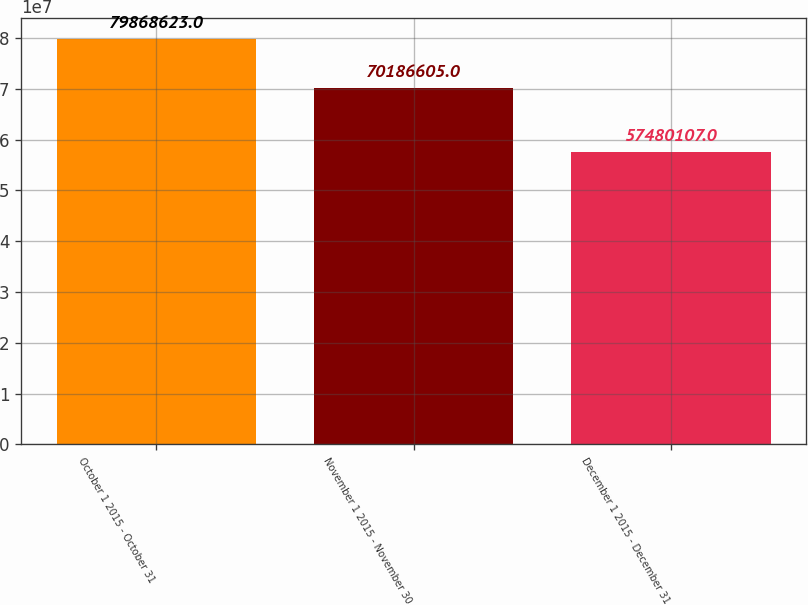Convert chart. <chart><loc_0><loc_0><loc_500><loc_500><bar_chart><fcel>October 1 2015 - October 31<fcel>November 1 2015 - November 30<fcel>December 1 2015 - December 31<nl><fcel>7.98686e+07<fcel>7.01866e+07<fcel>5.74801e+07<nl></chart> 